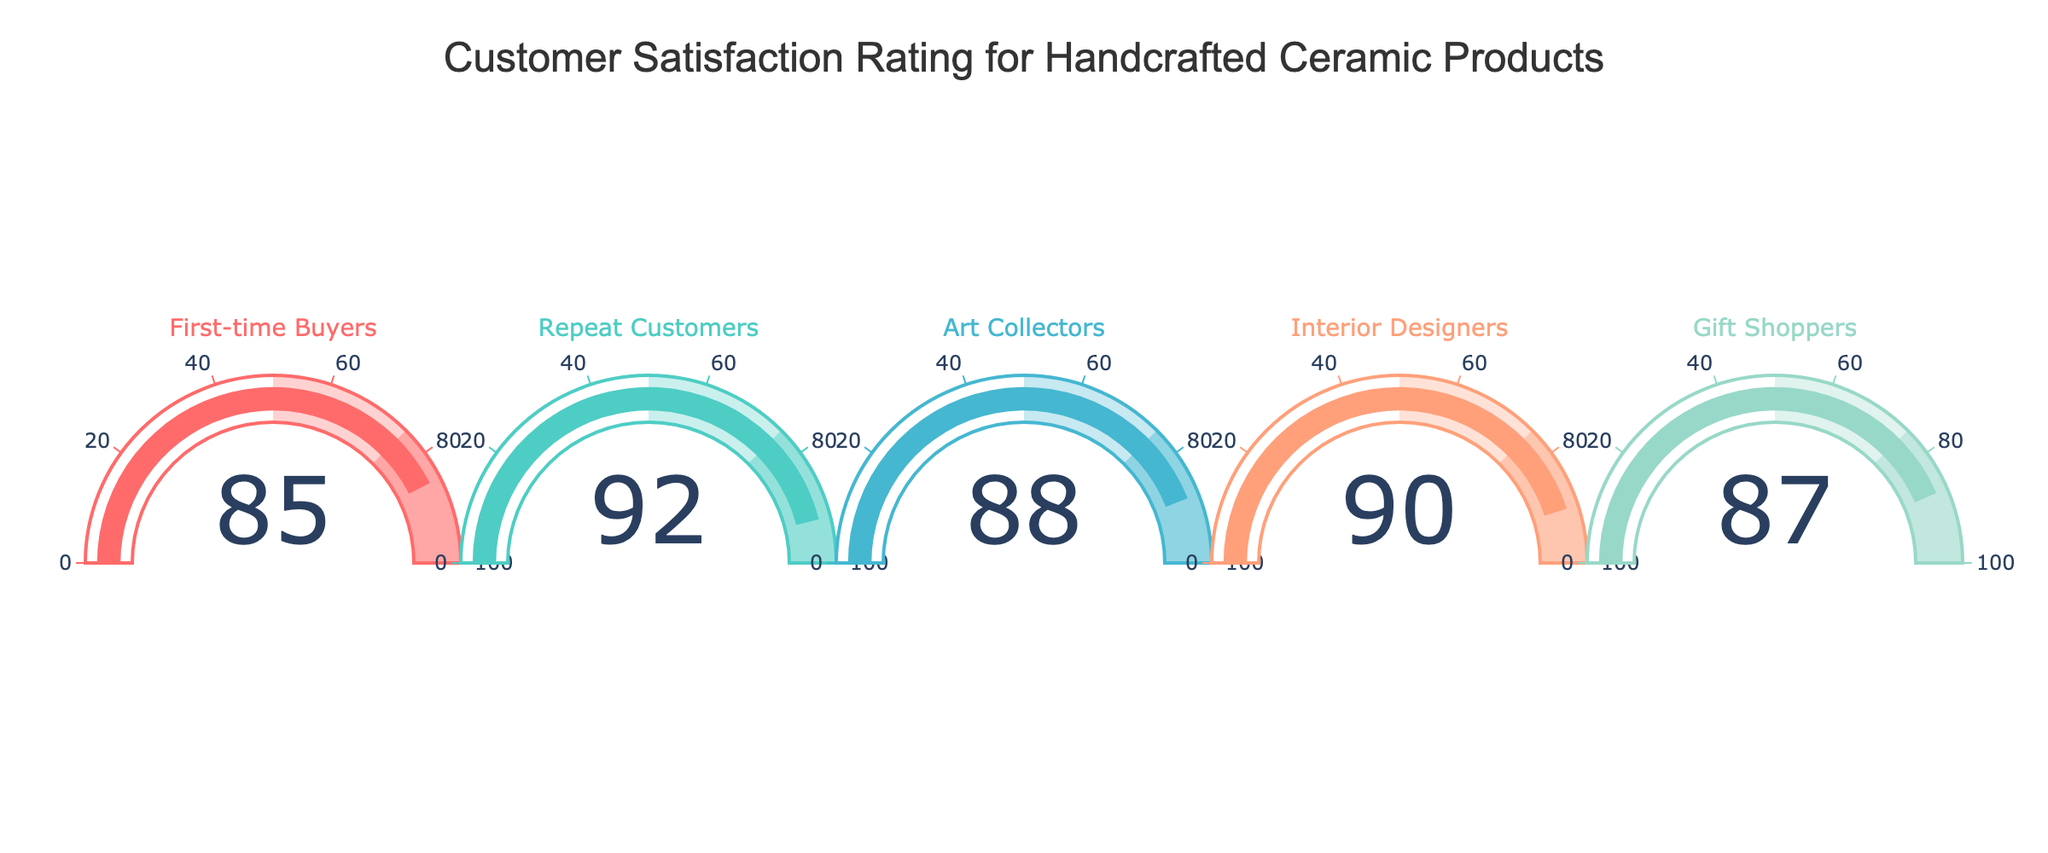What is the satisfaction rating for First-time Buyers? The figure shows each customer type's satisfaction rating on individual gauges. Look at the gauge labeled "First-time Buyers" to see the value displayed.
Answer: 85 What is the overall title of the figure? The overall title is typically positioned at the top of the figure. Look at the top center of the figure for this information.
Answer: Customer Satisfaction Rating for Handcrafted Ceramic Products Which customer type has the highest satisfaction rating? Compare the values displayed on all the gauges to determine which one is the highest.
Answer: Repeat Customers What is the difference in satisfaction rating between the lowest and highest customer type? Identify the highest and lowest satisfaction ratings from the gauges. Subtract the lowest rating from the highest rating to get the difference.
Answer: 92 - 85 = 7 How many distinct customer types are displayed in the figure? Count the number of individual gauges or the number of different labels to determine the number of distinct customer types.
Answer: 5 What is the median satisfaction rating among the customer types? List all the satisfaction ratings (85, 92, 88, 90, 87) and arrange them in ascending order (85, 87, 88, 90, 92). The median is the middle value in this ordered list.
Answer: 88 Are gift shoppers more satisfied than art collectors? Compare the satisfaction ratings of Gift Shoppers and Art Collectors displayed on their respective gauges.
Answer: No What would the satisfaction rating for a potential customer type "Ceramic Enthusiasts" need to be to have an average satisfaction rating of 90 among all customer types? First, calculate the total satisfaction ratings for the current 5 customer types (85 + 92 + 88 + 90 + 87 = 442). For an average of 90 with 6 customer types, the total should be 90 * 6 = 540. Subtract the current total from this desired total (540 - 442 = 98).
Answer: 98 Is the satisfaction rating for Interior Designers above 85? Check the gauge for Interior Designers and see if the satisfaction rating displayed is greater than 85.
Answer: Yes 